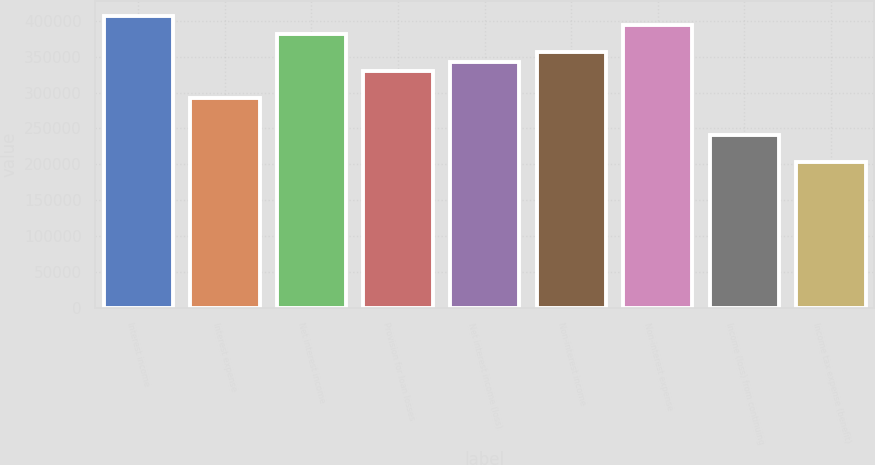Convert chart. <chart><loc_0><loc_0><loc_500><loc_500><bar_chart><fcel>Interest income<fcel>Interest expense<fcel>Net interest income<fcel>Provision for loan losses<fcel>Net interest income (loss)<fcel>Non-interest income<fcel>Non-interest expense<fcel>Income (loss) from continuing<fcel>Income tax expense (benefit)<nl><fcel>406560<fcel>292215<fcel>381150<fcel>330330<fcel>343035<fcel>355740<fcel>393855<fcel>241395<fcel>203280<nl></chart> 